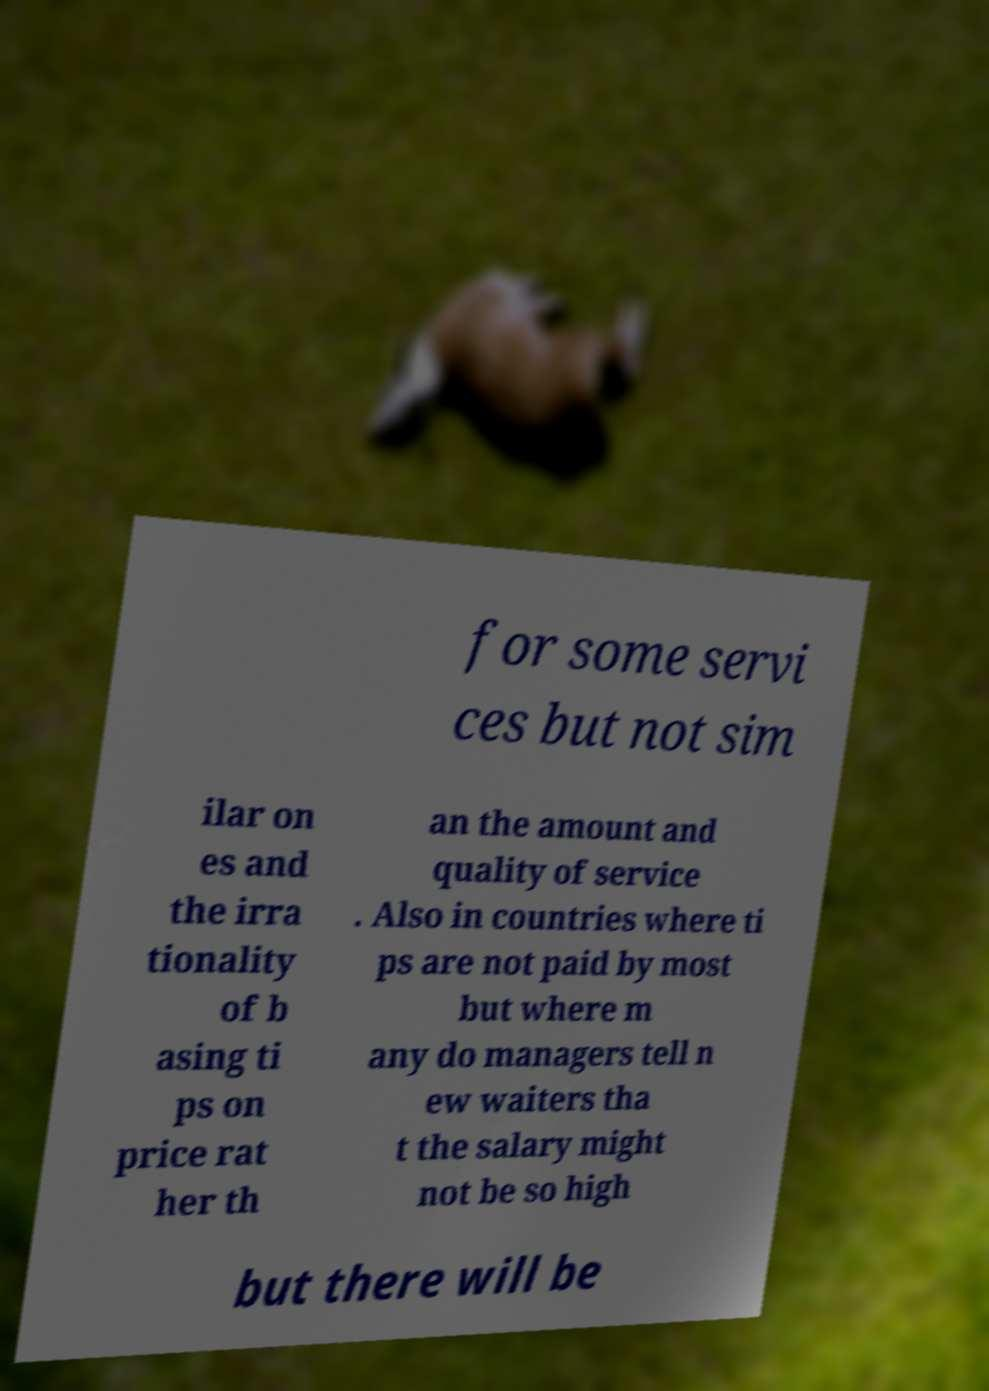Could you assist in decoding the text presented in this image and type it out clearly? for some servi ces but not sim ilar on es and the irra tionality of b asing ti ps on price rat her th an the amount and quality of service . Also in countries where ti ps are not paid by most but where m any do managers tell n ew waiters tha t the salary might not be so high but there will be 